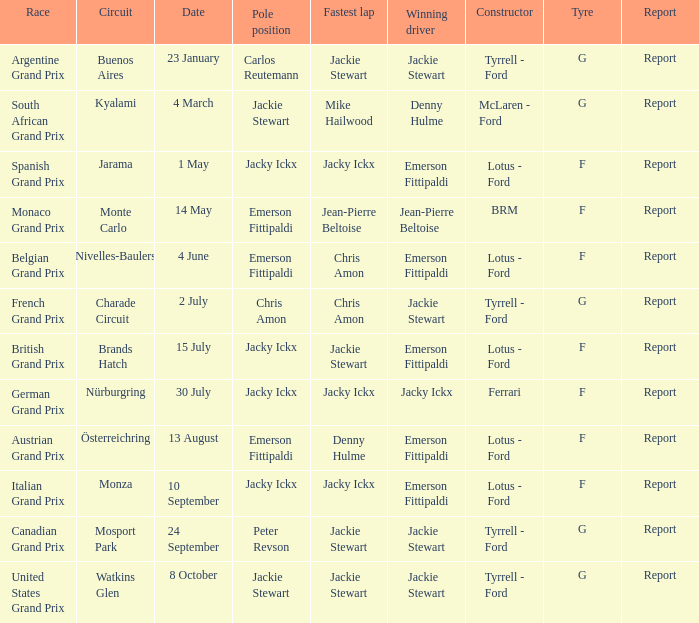Could you parse the entire table as a dict? {'header': ['Race', 'Circuit', 'Date', 'Pole position', 'Fastest lap', 'Winning driver', 'Constructor', 'Tyre', 'Report'], 'rows': [['Argentine Grand Prix', 'Buenos Aires', '23 January', 'Carlos Reutemann', 'Jackie Stewart', 'Jackie Stewart', 'Tyrrell - Ford', 'G', 'Report'], ['South African Grand Prix', 'Kyalami', '4 March', 'Jackie Stewart', 'Mike Hailwood', 'Denny Hulme', 'McLaren - Ford', 'G', 'Report'], ['Spanish Grand Prix', 'Jarama', '1 May', 'Jacky Ickx', 'Jacky Ickx', 'Emerson Fittipaldi', 'Lotus - Ford', 'F', 'Report'], ['Monaco Grand Prix', 'Monte Carlo', '14 May', 'Emerson Fittipaldi', 'Jean-Pierre Beltoise', 'Jean-Pierre Beltoise', 'BRM', 'F', 'Report'], ['Belgian Grand Prix', 'Nivelles-Baulers', '4 June', 'Emerson Fittipaldi', 'Chris Amon', 'Emerson Fittipaldi', 'Lotus - Ford', 'F', 'Report'], ['French Grand Prix', 'Charade Circuit', '2 July', 'Chris Amon', 'Chris Amon', 'Jackie Stewart', 'Tyrrell - Ford', 'G', 'Report'], ['British Grand Prix', 'Brands Hatch', '15 July', 'Jacky Ickx', 'Jackie Stewart', 'Emerson Fittipaldi', 'Lotus - Ford', 'F', 'Report'], ['German Grand Prix', 'Nürburgring', '30 July', 'Jacky Ickx', 'Jacky Ickx', 'Jacky Ickx', 'Ferrari', 'F', 'Report'], ['Austrian Grand Prix', 'Österreichring', '13 August', 'Emerson Fittipaldi', 'Denny Hulme', 'Emerson Fittipaldi', 'Lotus - Ford', 'F', 'Report'], ['Italian Grand Prix', 'Monza', '10 September', 'Jacky Ickx', 'Jacky Ickx', 'Emerson Fittipaldi', 'Lotus - Ford', 'F', 'Report'], ['Canadian Grand Prix', 'Mosport Park', '24 September', 'Peter Revson', 'Jackie Stewart', 'Jackie Stewart', 'Tyrrell - Ford', 'G', 'Report'], ['United States Grand Prix', 'Watkins Glen', '8 October', 'Jackie Stewart', 'Jackie Stewart', 'Jackie Stewart', 'Tyrrell - Ford', 'G', 'Report']]} Which circuit hosted the british grand prix? Brands Hatch. 